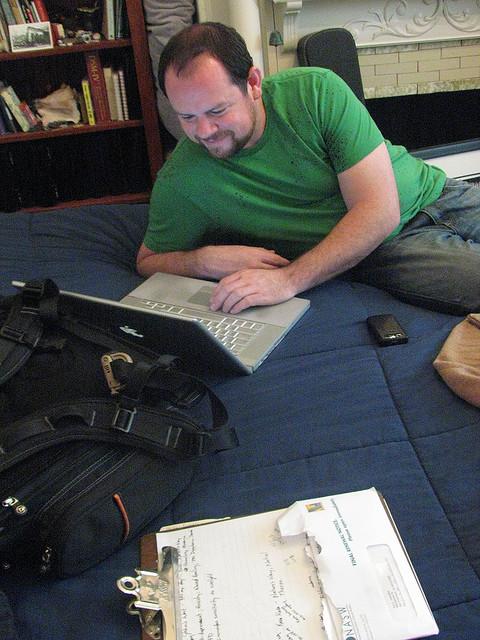What is on the bed next to the man?
Be succinct. Laptop. Is this in a dining room?
Short answer required. No. What is the brand of the laptop?
Keep it brief. Apple. What color is the man's shirt?
Write a very short answer. Green. 